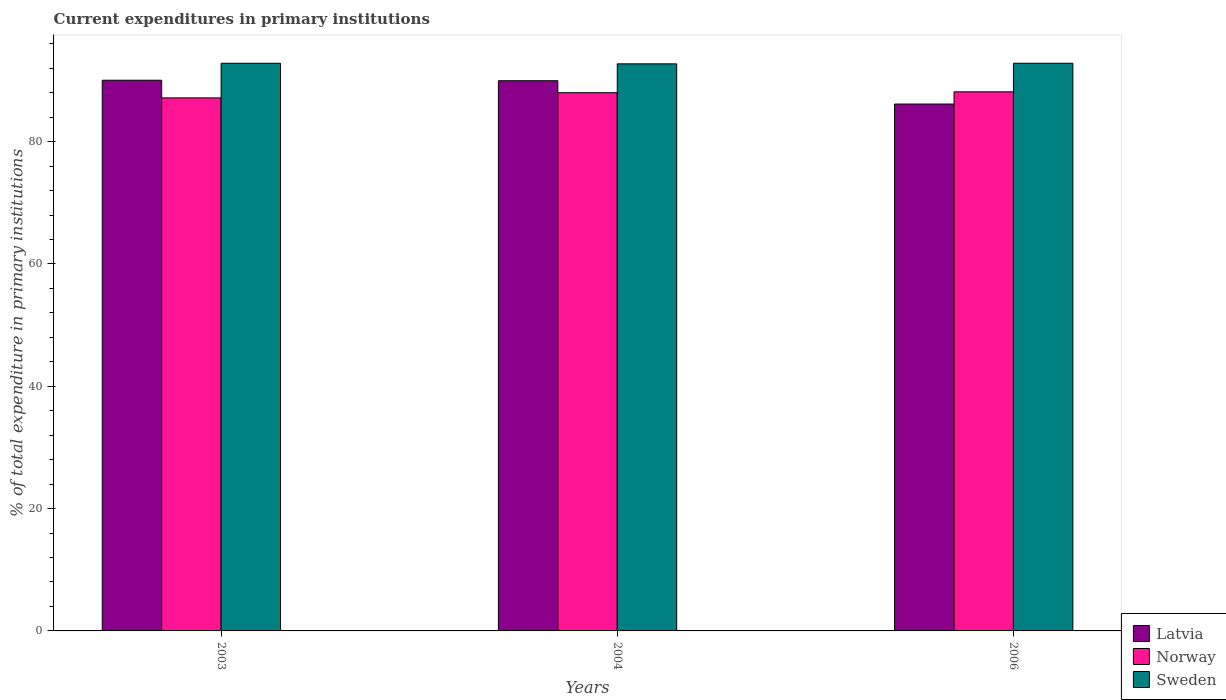Are the number of bars per tick equal to the number of legend labels?
Provide a short and direct response. Yes. How many bars are there on the 1st tick from the right?
Offer a terse response. 3. What is the label of the 1st group of bars from the left?
Ensure brevity in your answer.  2003. In how many cases, is the number of bars for a given year not equal to the number of legend labels?
Offer a very short reply. 0. What is the current expenditures in primary institutions in Norway in 2006?
Your answer should be very brief. 88.15. Across all years, what is the maximum current expenditures in primary institutions in Latvia?
Offer a very short reply. 90.05. Across all years, what is the minimum current expenditures in primary institutions in Norway?
Your answer should be very brief. 87.16. In which year was the current expenditures in primary institutions in Latvia minimum?
Your response must be concise. 2006. What is the total current expenditures in primary institutions in Norway in the graph?
Provide a succinct answer. 263.33. What is the difference between the current expenditures in primary institutions in Norway in 2004 and that in 2006?
Your response must be concise. -0.14. What is the difference between the current expenditures in primary institutions in Sweden in 2003 and the current expenditures in primary institutions in Norway in 2006?
Provide a short and direct response. 4.67. What is the average current expenditures in primary institutions in Sweden per year?
Your response must be concise. 92.79. In the year 2004, what is the difference between the current expenditures in primary institutions in Norway and current expenditures in primary institutions in Sweden?
Your answer should be compact. -4.71. In how many years, is the current expenditures in primary institutions in Norway greater than 56 %?
Offer a very short reply. 3. What is the ratio of the current expenditures in primary institutions in Sweden in 2004 to that in 2006?
Your answer should be compact. 1. What is the difference between the highest and the second highest current expenditures in primary institutions in Sweden?
Your response must be concise. 0. What is the difference between the highest and the lowest current expenditures in primary institutions in Sweden?
Your answer should be compact. 0.1. What does the 2nd bar from the right in 2004 represents?
Provide a short and direct response. Norway. How many bars are there?
Make the answer very short. 9. What is the difference between two consecutive major ticks on the Y-axis?
Provide a short and direct response. 20. Are the values on the major ticks of Y-axis written in scientific E-notation?
Ensure brevity in your answer.  No. Does the graph contain grids?
Keep it short and to the point. No. Where does the legend appear in the graph?
Make the answer very short. Bottom right. How are the legend labels stacked?
Your answer should be very brief. Vertical. What is the title of the graph?
Offer a terse response. Current expenditures in primary institutions. What is the label or title of the Y-axis?
Your answer should be compact. % of total expenditure in primary institutions. What is the % of total expenditure in primary institutions in Latvia in 2003?
Give a very brief answer. 90.05. What is the % of total expenditure in primary institutions in Norway in 2003?
Your answer should be very brief. 87.16. What is the % of total expenditure in primary institutions in Sweden in 2003?
Your answer should be very brief. 92.82. What is the % of total expenditure in primary institutions in Latvia in 2004?
Ensure brevity in your answer.  89.97. What is the % of total expenditure in primary institutions of Norway in 2004?
Offer a terse response. 88.01. What is the % of total expenditure in primary institutions in Sweden in 2004?
Offer a very short reply. 92.73. What is the % of total expenditure in primary institutions in Latvia in 2006?
Offer a very short reply. 86.16. What is the % of total expenditure in primary institutions of Norway in 2006?
Make the answer very short. 88.15. What is the % of total expenditure in primary institutions of Sweden in 2006?
Provide a succinct answer. 92.82. Across all years, what is the maximum % of total expenditure in primary institutions of Latvia?
Keep it short and to the point. 90.05. Across all years, what is the maximum % of total expenditure in primary institutions of Norway?
Give a very brief answer. 88.15. Across all years, what is the maximum % of total expenditure in primary institutions of Sweden?
Offer a very short reply. 92.82. Across all years, what is the minimum % of total expenditure in primary institutions in Latvia?
Offer a terse response. 86.16. Across all years, what is the minimum % of total expenditure in primary institutions in Norway?
Ensure brevity in your answer.  87.16. Across all years, what is the minimum % of total expenditure in primary institutions in Sweden?
Your response must be concise. 92.73. What is the total % of total expenditure in primary institutions of Latvia in the graph?
Provide a succinct answer. 266.17. What is the total % of total expenditure in primary institutions in Norway in the graph?
Your answer should be compact. 263.33. What is the total % of total expenditure in primary institutions in Sweden in the graph?
Offer a terse response. 278.37. What is the difference between the % of total expenditure in primary institutions in Latvia in 2003 and that in 2004?
Provide a short and direct response. 0.08. What is the difference between the % of total expenditure in primary institutions of Norway in 2003 and that in 2004?
Offer a terse response. -0.85. What is the difference between the % of total expenditure in primary institutions in Sweden in 2003 and that in 2004?
Your answer should be very brief. 0.09. What is the difference between the % of total expenditure in primary institutions in Latvia in 2003 and that in 2006?
Give a very brief answer. 3.89. What is the difference between the % of total expenditure in primary institutions in Norway in 2003 and that in 2006?
Your answer should be compact. -0.99. What is the difference between the % of total expenditure in primary institutions in Sweden in 2003 and that in 2006?
Offer a very short reply. -0. What is the difference between the % of total expenditure in primary institutions in Latvia in 2004 and that in 2006?
Your response must be concise. 3.81. What is the difference between the % of total expenditure in primary institutions of Norway in 2004 and that in 2006?
Ensure brevity in your answer.  -0.14. What is the difference between the % of total expenditure in primary institutions of Sweden in 2004 and that in 2006?
Ensure brevity in your answer.  -0.1. What is the difference between the % of total expenditure in primary institutions in Latvia in 2003 and the % of total expenditure in primary institutions in Norway in 2004?
Make the answer very short. 2.04. What is the difference between the % of total expenditure in primary institutions in Latvia in 2003 and the % of total expenditure in primary institutions in Sweden in 2004?
Keep it short and to the point. -2.68. What is the difference between the % of total expenditure in primary institutions in Norway in 2003 and the % of total expenditure in primary institutions in Sweden in 2004?
Offer a terse response. -5.56. What is the difference between the % of total expenditure in primary institutions of Latvia in 2003 and the % of total expenditure in primary institutions of Norway in 2006?
Keep it short and to the point. 1.9. What is the difference between the % of total expenditure in primary institutions of Latvia in 2003 and the % of total expenditure in primary institutions of Sweden in 2006?
Ensure brevity in your answer.  -2.77. What is the difference between the % of total expenditure in primary institutions of Norway in 2003 and the % of total expenditure in primary institutions of Sweden in 2006?
Offer a very short reply. -5.66. What is the difference between the % of total expenditure in primary institutions of Latvia in 2004 and the % of total expenditure in primary institutions of Norway in 2006?
Ensure brevity in your answer.  1.82. What is the difference between the % of total expenditure in primary institutions in Latvia in 2004 and the % of total expenditure in primary institutions in Sweden in 2006?
Keep it short and to the point. -2.86. What is the difference between the % of total expenditure in primary institutions of Norway in 2004 and the % of total expenditure in primary institutions of Sweden in 2006?
Make the answer very short. -4.81. What is the average % of total expenditure in primary institutions of Latvia per year?
Your response must be concise. 88.72. What is the average % of total expenditure in primary institutions of Norway per year?
Give a very brief answer. 87.78. What is the average % of total expenditure in primary institutions of Sweden per year?
Provide a succinct answer. 92.79. In the year 2003, what is the difference between the % of total expenditure in primary institutions of Latvia and % of total expenditure in primary institutions of Norway?
Provide a short and direct response. 2.89. In the year 2003, what is the difference between the % of total expenditure in primary institutions in Latvia and % of total expenditure in primary institutions in Sweden?
Your response must be concise. -2.77. In the year 2003, what is the difference between the % of total expenditure in primary institutions of Norway and % of total expenditure in primary institutions of Sweden?
Keep it short and to the point. -5.66. In the year 2004, what is the difference between the % of total expenditure in primary institutions of Latvia and % of total expenditure in primary institutions of Norway?
Keep it short and to the point. 1.95. In the year 2004, what is the difference between the % of total expenditure in primary institutions in Latvia and % of total expenditure in primary institutions in Sweden?
Provide a succinct answer. -2.76. In the year 2004, what is the difference between the % of total expenditure in primary institutions of Norway and % of total expenditure in primary institutions of Sweden?
Your response must be concise. -4.71. In the year 2006, what is the difference between the % of total expenditure in primary institutions in Latvia and % of total expenditure in primary institutions in Norway?
Offer a very short reply. -2. In the year 2006, what is the difference between the % of total expenditure in primary institutions of Latvia and % of total expenditure in primary institutions of Sweden?
Provide a short and direct response. -6.67. In the year 2006, what is the difference between the % of total expenditure in primary institutions in Norway and % of total expenditure in primary institutions in Sweden?
Your answer should be compact. -4.67. What is the ratio of the % of total expenditure in primary institutions of Latvia in 2003 to that in 2004?
Your answer should be very brief. 1. What is the ratio of the % of total expenditure in primary institutions of Norway in 2003 to that in 2004?
Offer a terse response. 0.99. What is the ratio of the % of total expenditure in primary institutions in Latvia in 2003 to that in 2006?
Your response must be concise. 1.05. What is the ratio of the % of total expenditure in primary institutions of Norway in 2003 to that in 2006?
Your answer should be compact. 0.99. What is the ratio of the % of total expenditure in primary institutions of Sweden in 2003 to that in 2006?
Provide a succinct answer. 1. What is the ratio of the % of total expenditure in primary institutions in Latvia in 2004 to that in 2006?
Provide a short and direct response. 1.04. What is the difference between the highest and the second highest % of total expenditure in primary institutions in Latvia?
Your answer should be very brief. 0.08. What is the difference between the highest and the second highest % of total expenditure in primary institutions in Norway?
Keep it short and to the point. 0.14. What is the difference between the highest and the second highest % of total expenditure in primary institutions in Sweden?
Your response must be concise. 0. What is the difference between the highest and the lowest % of total expenditure in primary institutions of Latvia?
Ensure brevity in your answer.  3.89. What is the difference between the highest and the lowest % of total expenditure in primary institutions in Sweden?
Make the answer very short. 0.1. 